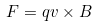Convert formula to latex. <formula><loc_0><loc_0><loc_500><loc_500>F = q v \times B</formula> 